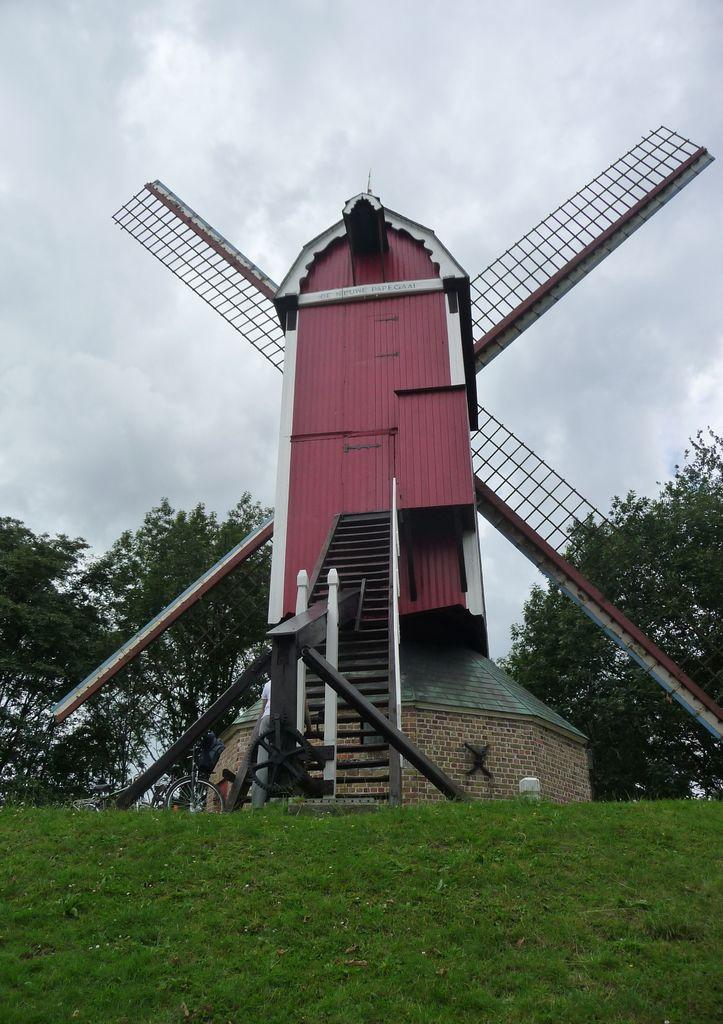What is the main structure featured in the picture? There is a windmill in the picture. What can be seen on the left side of the picture? There is a bicycle on the left side of the picture. What type of vegetation is present in the picture? There is green grass in the picture. What else is visible in the picture besides the windmill and bicycle? There are trees in the picture. What is visible in the sky in the picture? There are clouds visible in the sky. What type of jam is being spread on the windmill in the picture? There is no jam or any indication of spreading it in the picture; it features a windmill and a bicycle. 